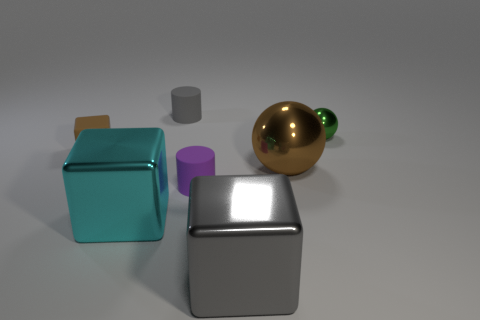Subtract all tiny blocks. How many blocks are left? 2 Add 3 green shiny things. How many objects exist? 10 Subtract all brown blocks. How many blocks are left? 2 Subtract all balls. How many objects are left? 5 Add 5 small cubes. How many small cubes exist? 6 Subtract 0 yellow balls. How many objects are left? 7 Subtract 2 balls. How many balls are left? 0 Subtract all blue cubes. Subtract all purple balls. How many cubes are left? 3 Subtract all red balls. How many cyan cubes are left? 1 Subtract all rubber blocks. Subtract all brown objects. How many objects are left? 4 